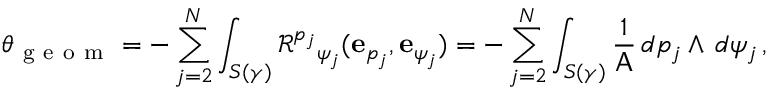<formula> <loc_0><loc_0><loc_500><loc_500>\theta _ { g e o m } = - \sum _ { j = 2 } ^ { N } \int _ { S ( \gamma ) } \mathcal { R } ^ { p _ { j } _ { \psi _ { j } } ( e _ { p _ { j } } , e _ { \psi _ { j } } ) = - \sum _ { j = 2 } ^ { N } \int _ { S ( \gamma ) } \frac { 1 } { A } \, d p _ { j } \wedge \, d \psi _ { j } \, ,</formula> 